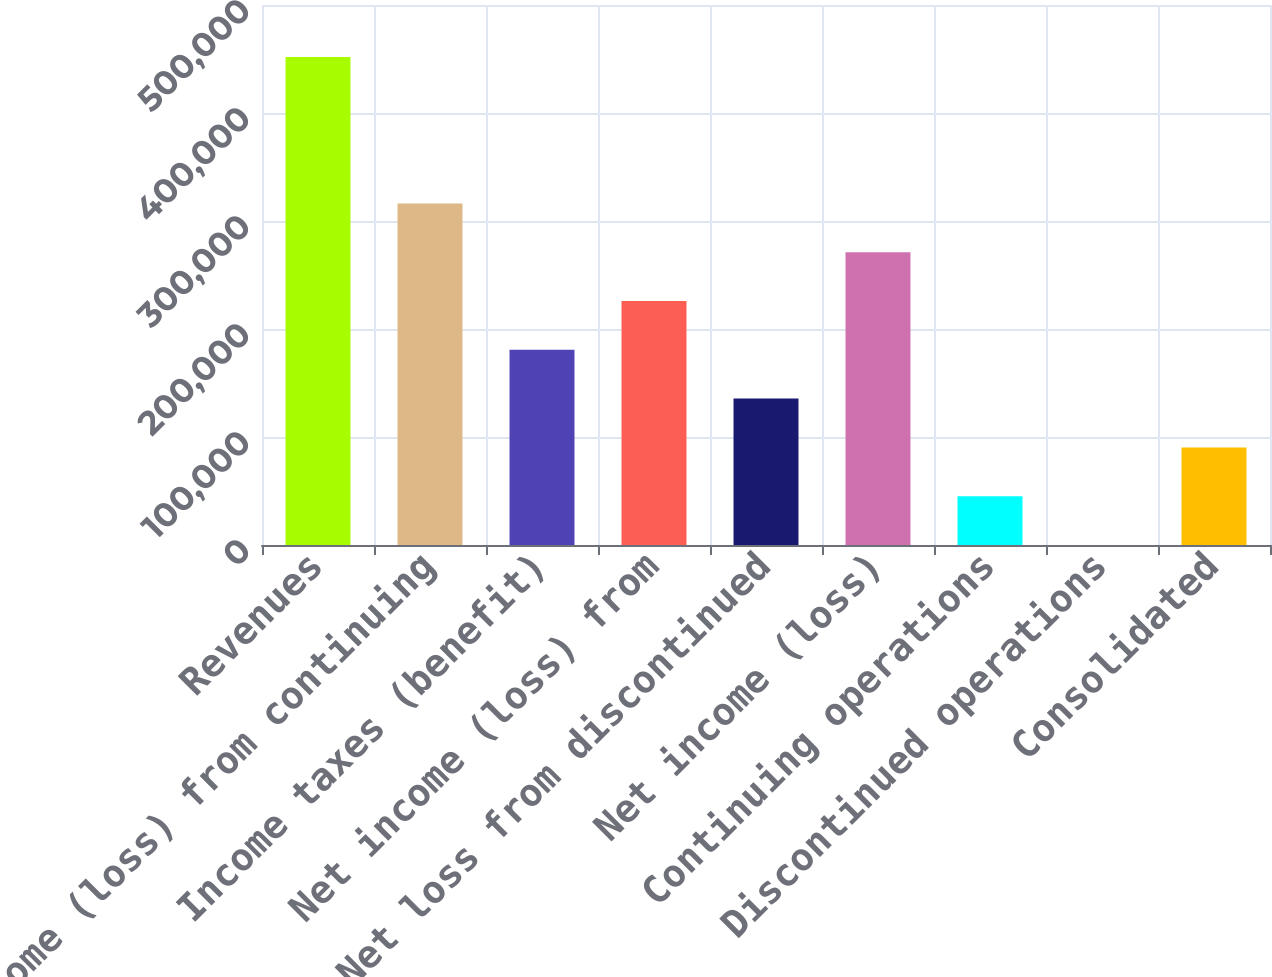Convert chart. <chart><loc_0><loc_0><loc_500><loc_500><bar_chart><fcel>Revenues<fcel>Income (loss) from continuing<fcel>Income taxes (benefit)<fcel>Net income (loss) from<fcel>Net loss from discontinued<fcel>Net income (loss)<fcel>Continuing operations<fcel>Discontinued operations<fcel>Consolidated<nl><fcel>451882<fcel>316317<fcel>180753<fcel>225941<fcel>135565<fcel>271129<fcel>45188.2<fcel>0.01<fcel>90376.4<nl></chart> 